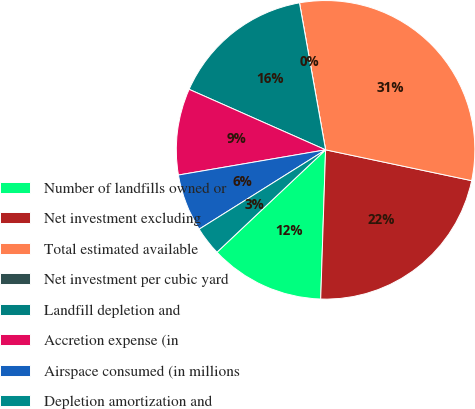<chart> <loc_0><loc_0><loc_500><loc_500><pie_chart><fcel>Number of landfills owned or<fcel>Net investment excluding<fcel>Total estimated available<fcel>Net investment per cubic yard<fcel>Landfill depletion and<fcel>Accretion expense (in<fcel>Airspace consumed (in millions<fcel>Depletion amortization and<nl><fcel>12.45%<fcel>22.21%<fcel>31.11%<fcel>0.0%<fcel>15.56%<fcel>9.34%<fcel>6.22%<fcel>3.11%<nl></chart> 